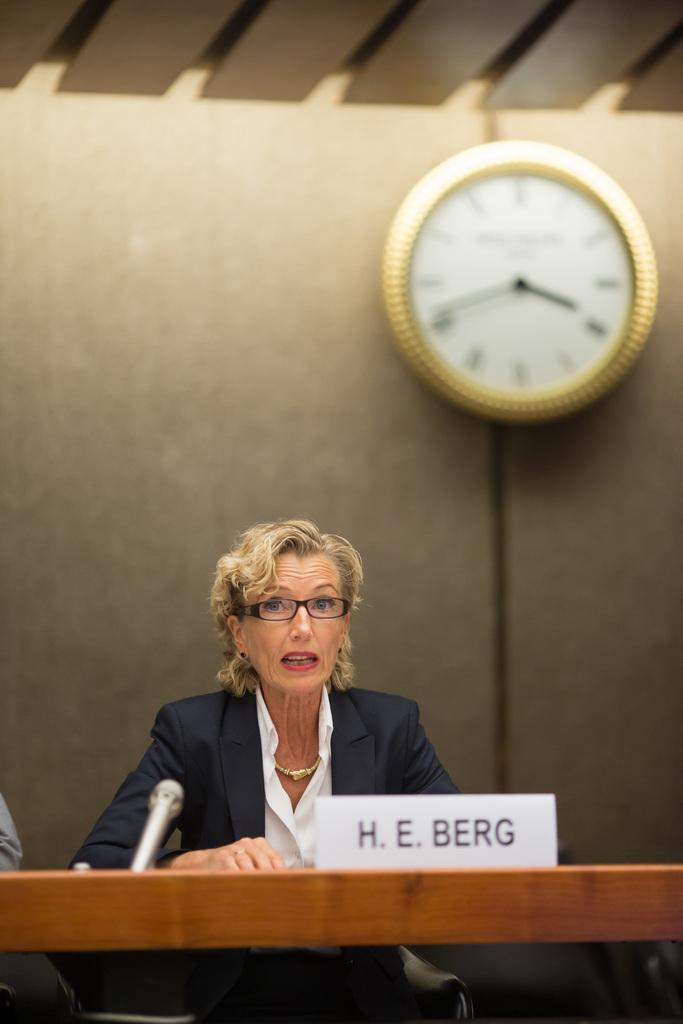Provide a one-sentence caption for the provided image. H.E. Berg is seated at a table with a microphone. 